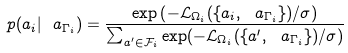<formula> <loc_0><loc_0><loc_500><loc_500>p ( a _ { i } | \ a _ { \Gamma _ { i } } ) = \frac { \exp \left ( - \mathcal { L } _ { \Omega _ { i } } ( \{ a _ { i } , \ a _ { \Gamma _ { i } } \} ) / \sigma \right ) } { \sum _ { a ^ { \prime } \in \mathcal { F } _ { i } } \exp ( - \mathcal { L } _ { \Omega _ { i } } ( \{ a ^ { \prime } , \ a _ { \Gamma _ { i } } \} ) / \sigma ) }</formula> 